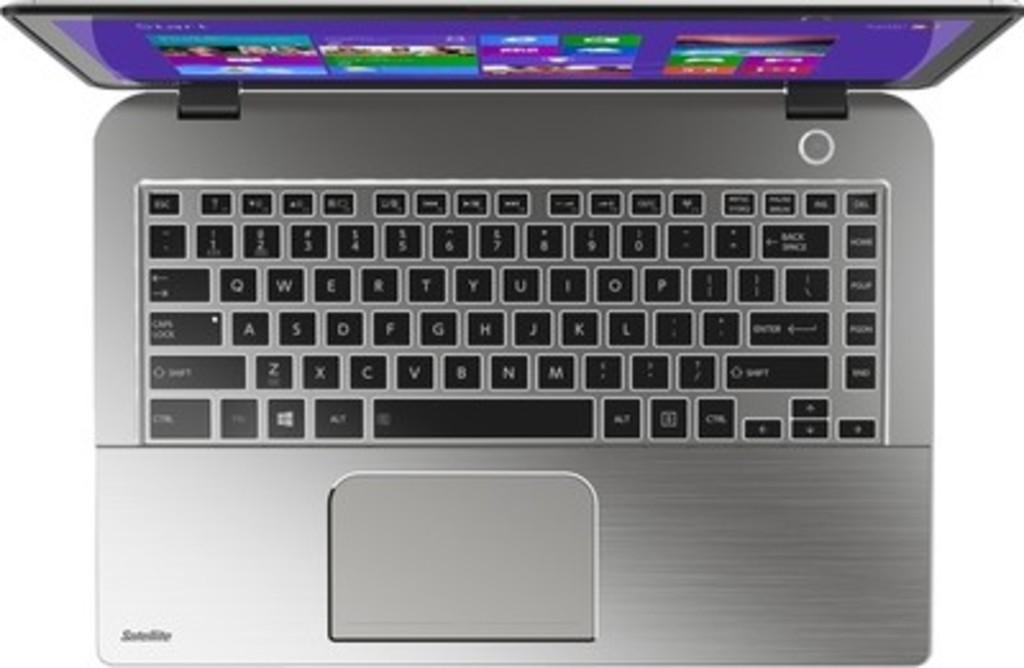What electronic device is visible in the image? There is a laptop in the image. What can be seen on the laptop screen? The laptop screen displays colorful images. What is the color of the key buttons on the laptop? The key buttons on the laptop are black in color. How many bears are sitting on the kettle in the image? There are no bears or kettle present in the image. 